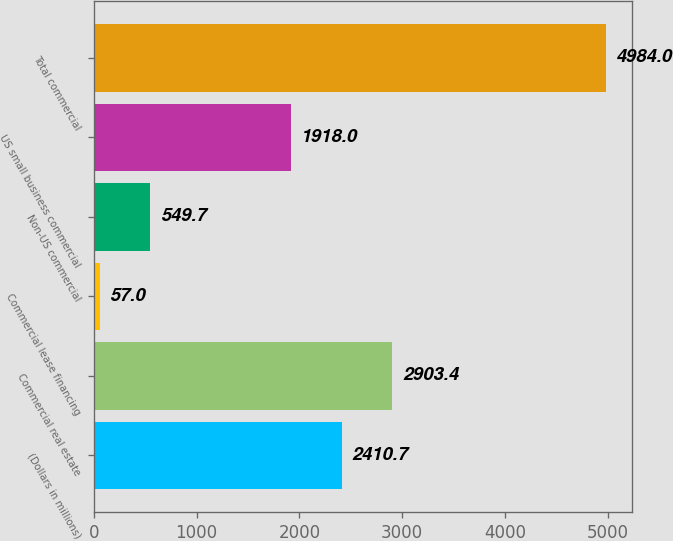<chart> <loc_0><loc_0><loc_500><loc_500><bar_chart><fcel>(Dollars in millions)<fcel>Commercial real estate<fcel>Commercial lease financing<fcel>Non-US commercial<fcel>US small business commercial<fcel>Total commercial<nl><fcel>2410.7<fcel>2903.4<fcel>57<fcel>549.7<fcel>1918<fcel>4984<nl></chart> 